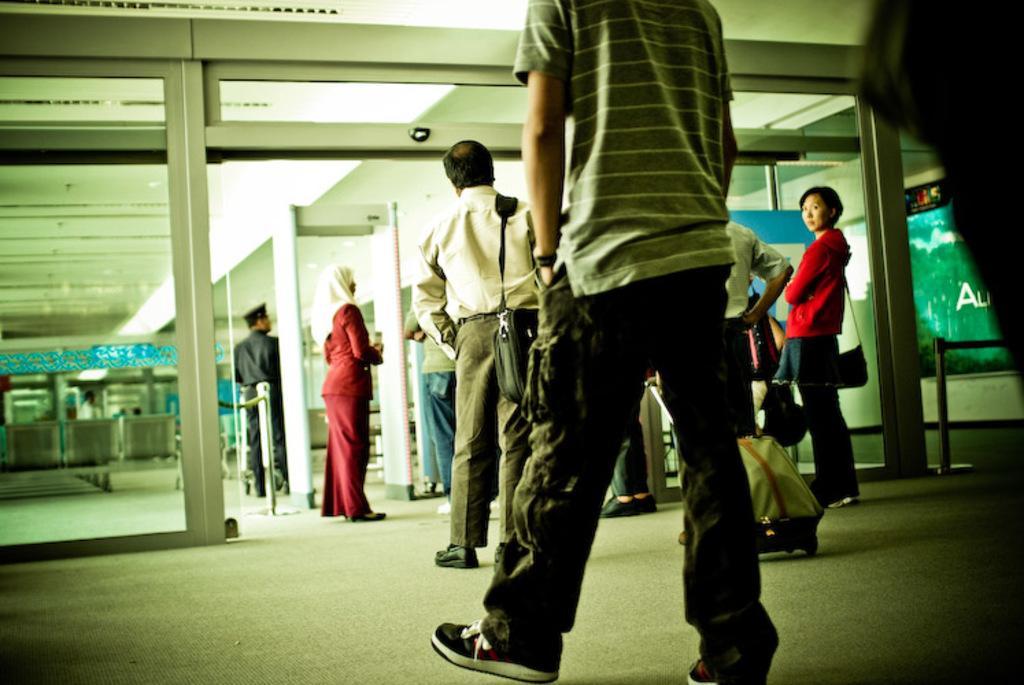Describe this image in one or two sentences. In this picture I can see number of people standing in front and I see that few of them are wearing bags and on the right side of this picture I can see a board on which there is something written. In the background I can see an electronic equipment and I can see the glasses and the walls. 